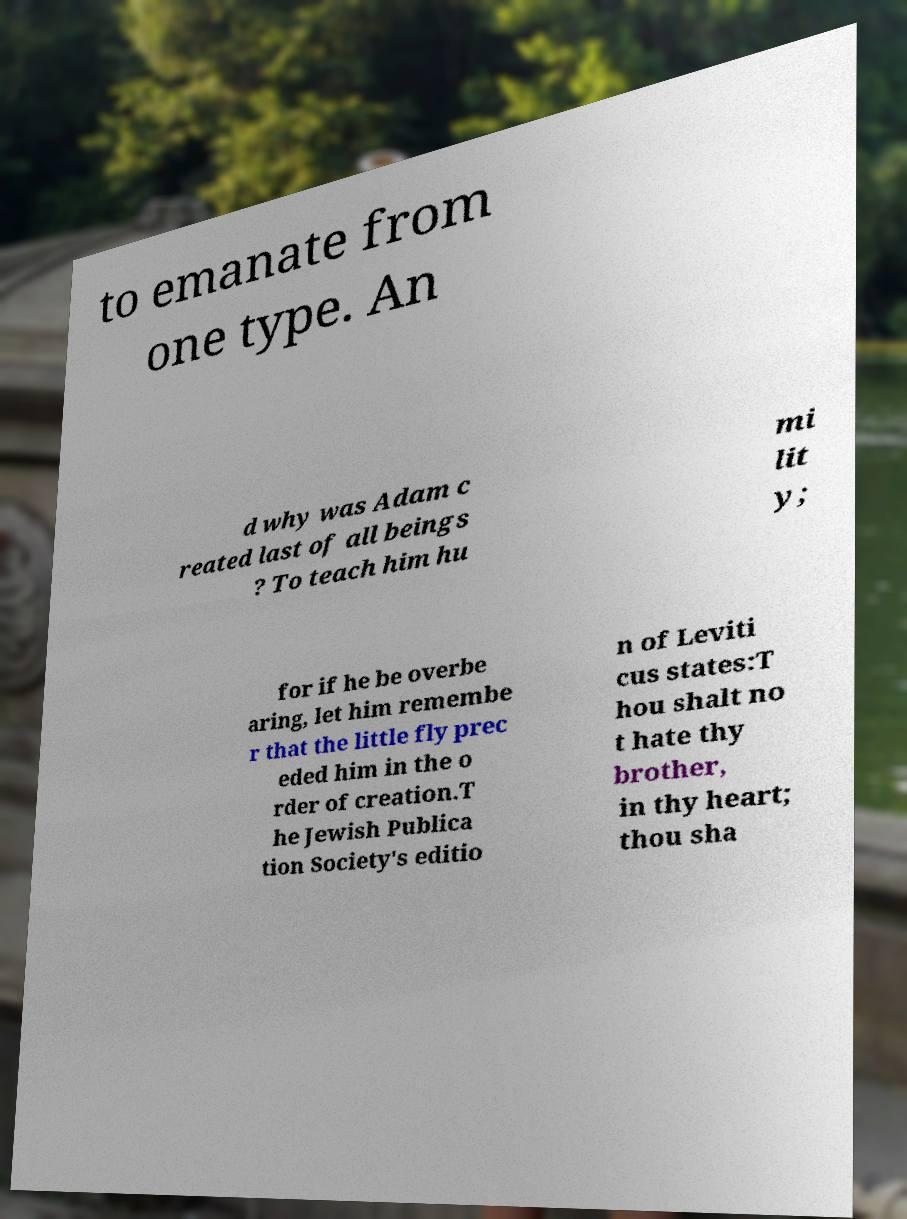Can you accurately transcribe the text from the provided image for me? to emanate from one type. An d why was Adam c reated last of all beings ? To teach him hu mi lit y; for if he be overbe aring, let him remembe r that the little fly prec eded him in the o rder of creation.T he Jewish Publica tion Society's editio n of Leviti cus states:T hou shalt no t hate thy brother, in thy heart; thou sha 